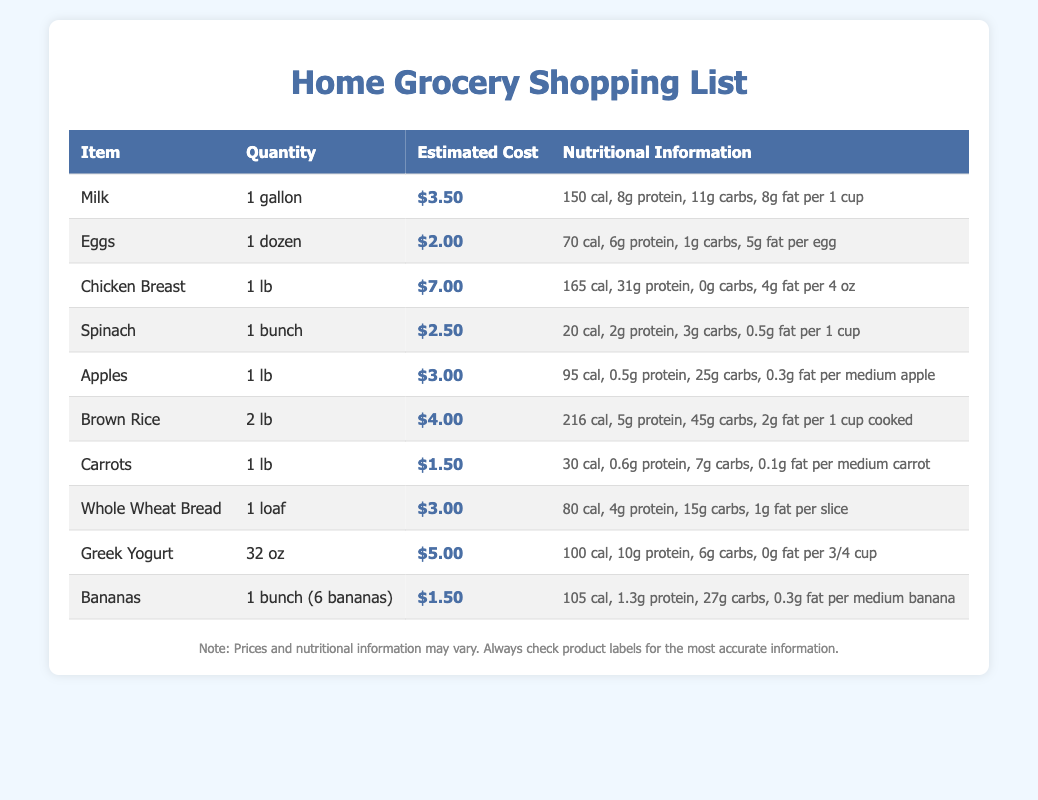What is the estimated cost of Chicken Breast? The estimated cost of Chicken Breast is stated directly in the document.
Answer: $7.00 How many calories are in 1 medium banana? The nutritional information for bananas specifies their caloric content per medium banana.
Answer: 105 cal What quantity of Spinach is listed? The document specifies the quantity of Spinach for purchase.
Answer: 1 bunch Which item has the highest protein content per serving? By comparing the protein values in the nutritional information, Chicken Breast has the highest protein content.
Answer: Chicken Breast What is the total estimated cost for all items? The total cost can be calculated by adding all the individual estimated costs from the document.
Answer: $30.00 How many carbs are in 1 slice of Whole Wheat Bread? The nutritional information outlines the carbohydrate content per slice of Whole Wheat Bread.
Answer: 15g carbs How much does a dozen Eggs cost? The document provides the estimated cost for one dozen Eggs.
Answer: $2.00 What is the nutritional information for Greek Yogurt per serving? The document provides specific nutritional information for Greek Yogurt based on the serving size mentioned.
Answer: 100 cal, 10g protein, 6g carbs, 0g fat per 3/4 cup 